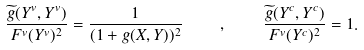Convert formula to latex. <formula><loc_0><loc_0><loc_500><loc_500>\frac { \widetilde { g } ( Y ^ { v } , Y ^ { v } ) } { F ^ { v } ( Y ^ { v } ) ^ { 2 } } = \frac { 1 } { ( 1 + g ( X , Y ) ) ^ { 2 } } \quad , \quad \frac { \widetilde { g } ( Y ^ { c } , Y ^ { c } ) } { F ^ { v } ( Y ^ { c } ) ^ { 2 } } = 1 .</formula> 